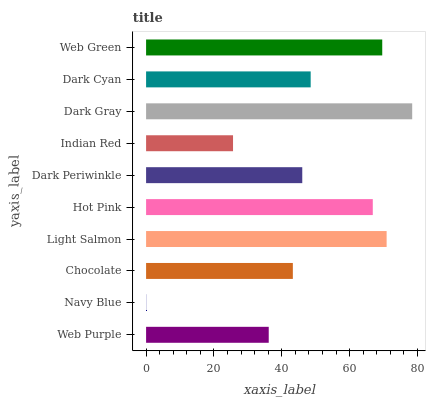Is Navy Blue the minimum?
Answer yes or no. Yes. Is Dark Gray the maximum?
Answer yes or no. Yes. Is Chocolate the minimum?
Answer yes or no. No. Is Chocolate the maximum?
Answer yes or no. No. Is Chocolate greater than Navy Blue?
Answer yes or no. Yes. Is Navy Blue less than Chocolate?
Answer yes or no. Yes. Is Navy Blue greater than Chocolate?
Answer yes or no. No. Is Chocolate less than Navy Blue?
Answer yes or no. No. Is Dark Cyan the high median?
Answer yes or no. Yes. Is Dark Periwinkle the low median?
Answer yes or no. Yes. Is Dark Gray the high median?
Answer yes or no. No. Is Navy Blue the low median?
Answer yes or no. No. 